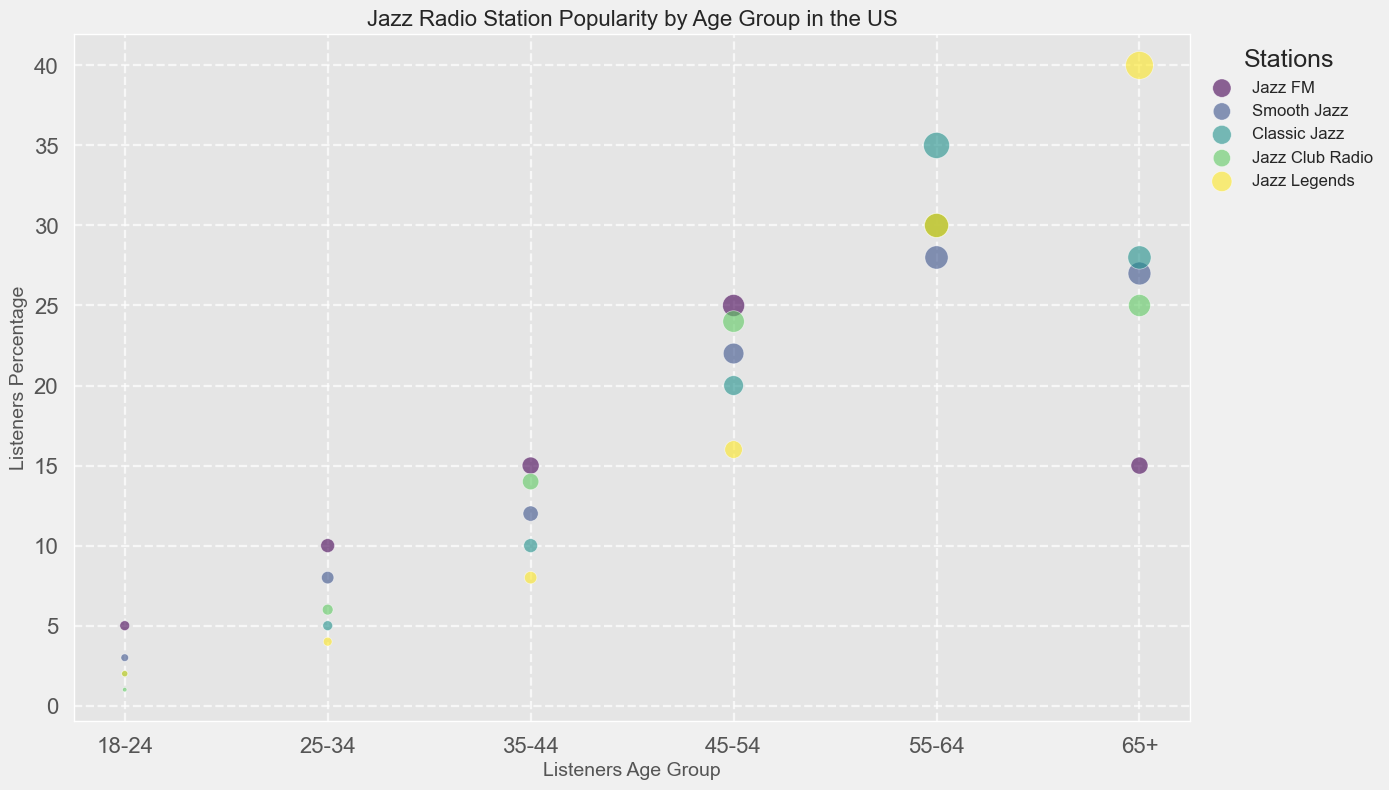What is the age group with the highest listeners percentage for Jazz Legends? We need to look at the age groups for Jazz Legends and identify which one has the highest percentage. The listeners percentages for Jazz Legends are 2%, 4%, 8%, 16%, 30%, and 40%. The highest value is 40% which corresponds to the 65+ age group.
Answer: 65+ Which station has the largest percentage of listeners in the 18-24 age group? Look at the percentages of listeners in the 18-24 age group across all stations. The values are 5% (Jazz FM), 3% (Smooth Jazz), 2% (Classic Jazz), 1% (Jazz Club Radio), and 2% (Jazz Legends). The highest value is 5% for Jazz FM.
Answer: Jazz FM How does the percentage of listeners in the 55-64 age group compare between Classic Jazz and Smooth Jazz? Look at the listeners percentages in the 55-64 age group for both Classic Jazz and Smooth Jazz. For Classic Jazz, it is 35%, and for Smooth Jazz, it is 28%. Classic Jazz has a higher percentage of 55-64-year-old listeners than Smooth Jazz.
Answer: Classic Jazz has a higher percentage Which age group has the lowest percentage of listeners for Jazz Club Radio? Look at the percentages of listeners in all age groups for Jazz Club Radio. The values are 1%, 6%, 14%, 24%, 30%, and 25%. The lowest percentage is 1%, which corresponds to the 18-24 age group.
Answer: 18-24 What is the average percentage of listeners for Smooth Jazz across all age groups? Sum the percentages of listeners for Smooth Jazz across all age groups and divide by the number of age groups. The values are 3%, 8%, 12%, 22%, 28%, and 27%. The sum is 100%, and there are 6 age groups, so the average is 100% / 6 ≈ 16.67%.
Answer: ~16.67% If we merge the percentage of listeners in the 18-24 and 25-34 age groups for Jazz FM, what is the result? Add the percentages of listeners in the 18-24 and 25-34 age groups for Jazz FM. The values are 5% and 10%, respectively. The sum is 5% + 10% = 15%.
Answer: 15% Between Jazz FM and Jazz Legends, which station has a higher percentage of listeners in the 45-54 age group? Compare the percentages of listeners in the 45-54 age group for Jazz FM and Jazz Legends. Jazz FM has 25%, and Jazz Legends has 16%. Jazz FM has a higher percentage.
Answer: Jazz FM Which station has a higher overall airplay hours per week, Jazz Club Radio or Jazz FM? Look at the airplay hours per week for Jazz Club Radio and Jazz FM. Jazz Club Radio has 45 hours per week, and Jazz FM has 40 hours per week. Jazz Club Radio has higher airplay hours.
Answer: Jazz Club Radio 